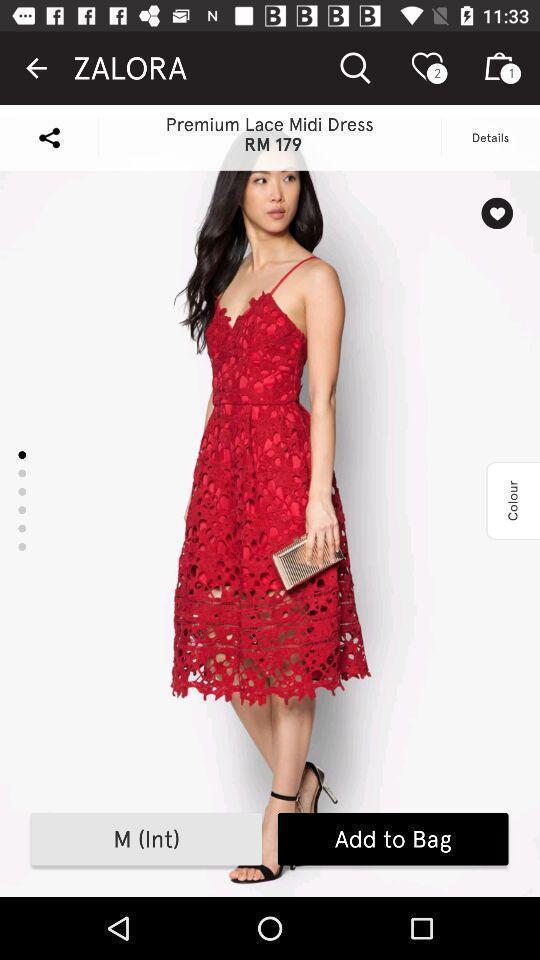Tell me what you see in this picture. Page showing the product in shopping app. 